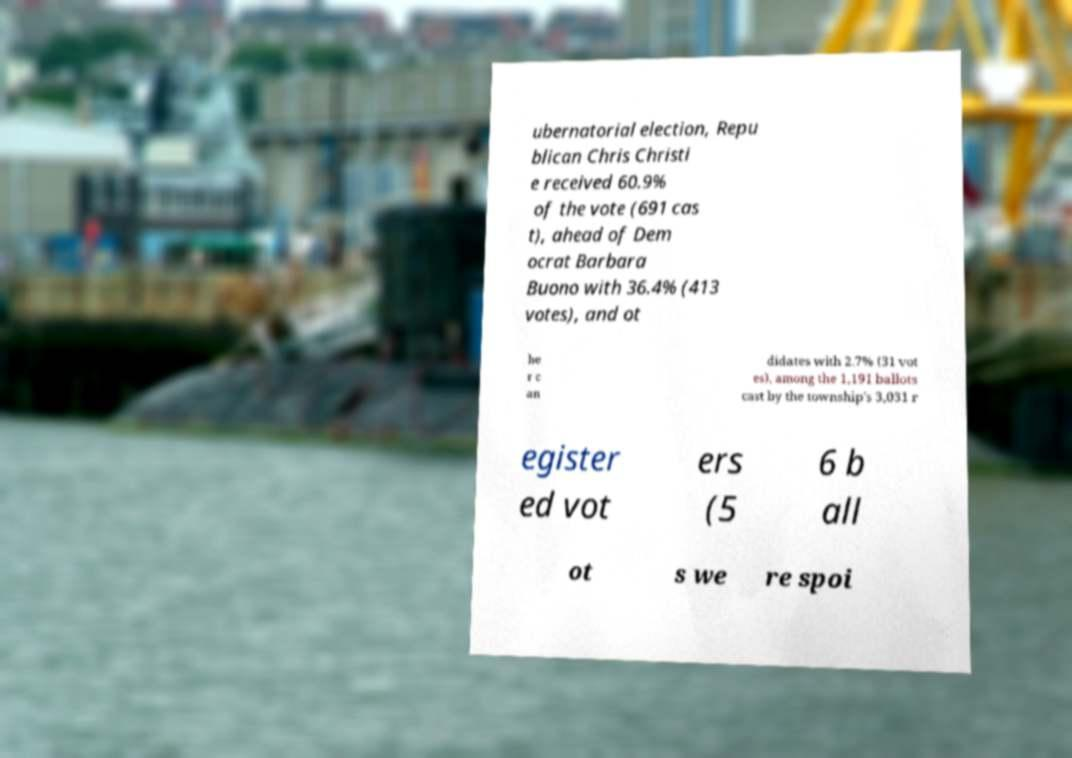Could you extract and type out the text from this image? ubernatorial election, Repu blican Chris Christi e received 60.9% of the vote (691 cas t), ahead of Dem ocrat Barbara Buono with 36.4% (413 votes), and ot he r c an didates with 2.7% (31 vot es), among the 1,191 ballots cast by the township's 3,031 r egister ed vot ers (5 6 b all ot s we re spoi 